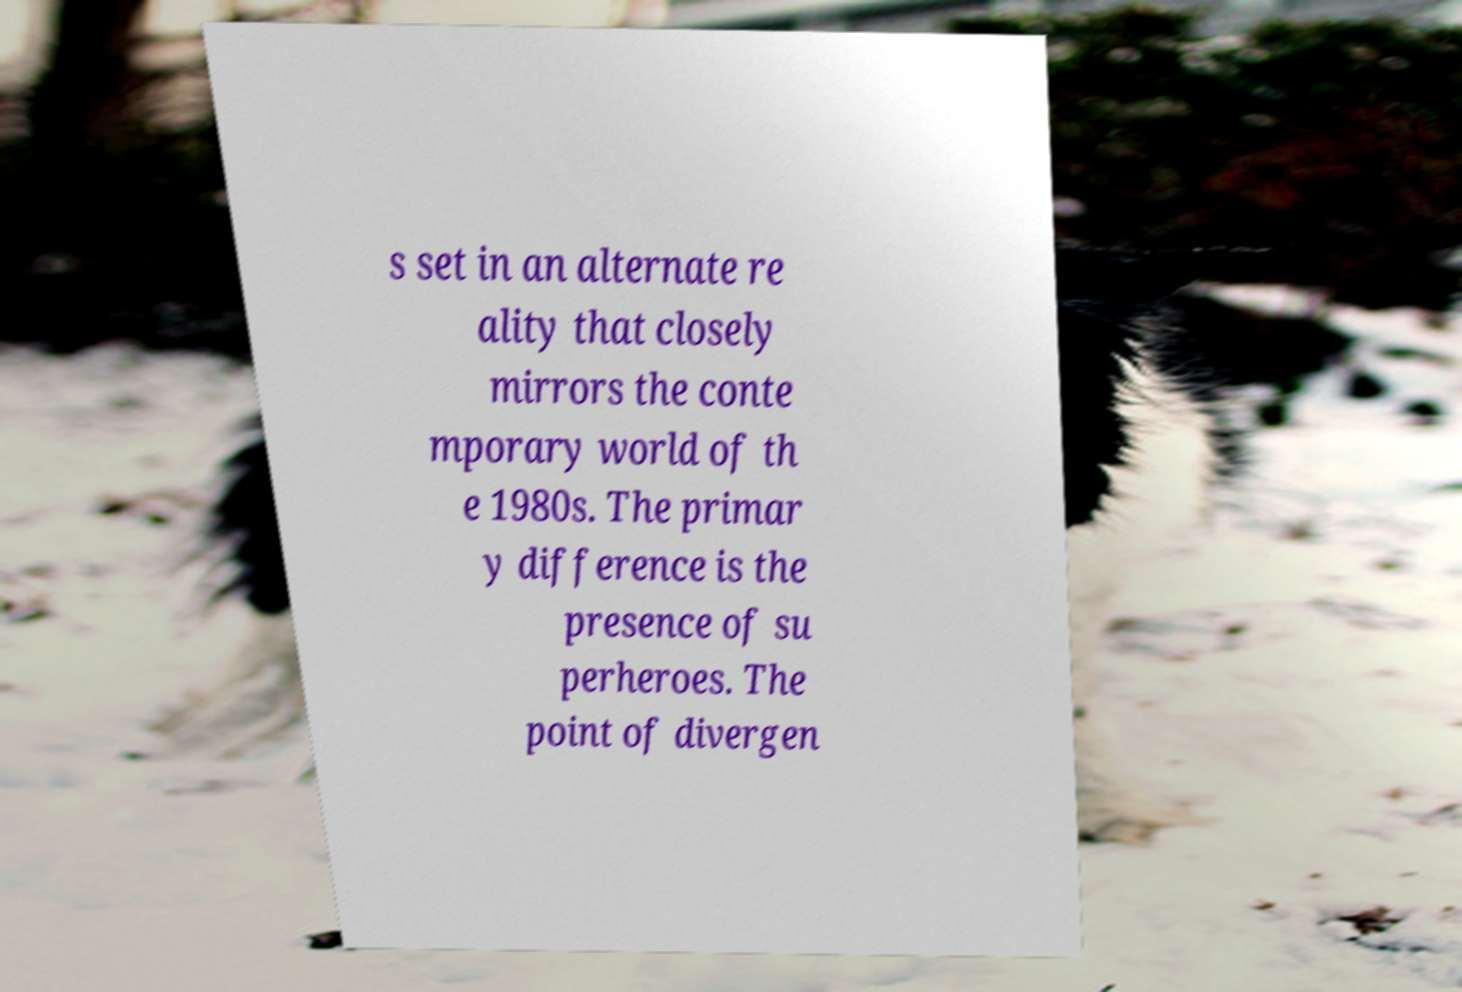Can you accurately transcribe the text from the provided image for me? s set in an alternate re ality that closely mirrors the conte mporary world of th e 1980s. The primar y difference is the presence of su perheroes. The point of divergen 